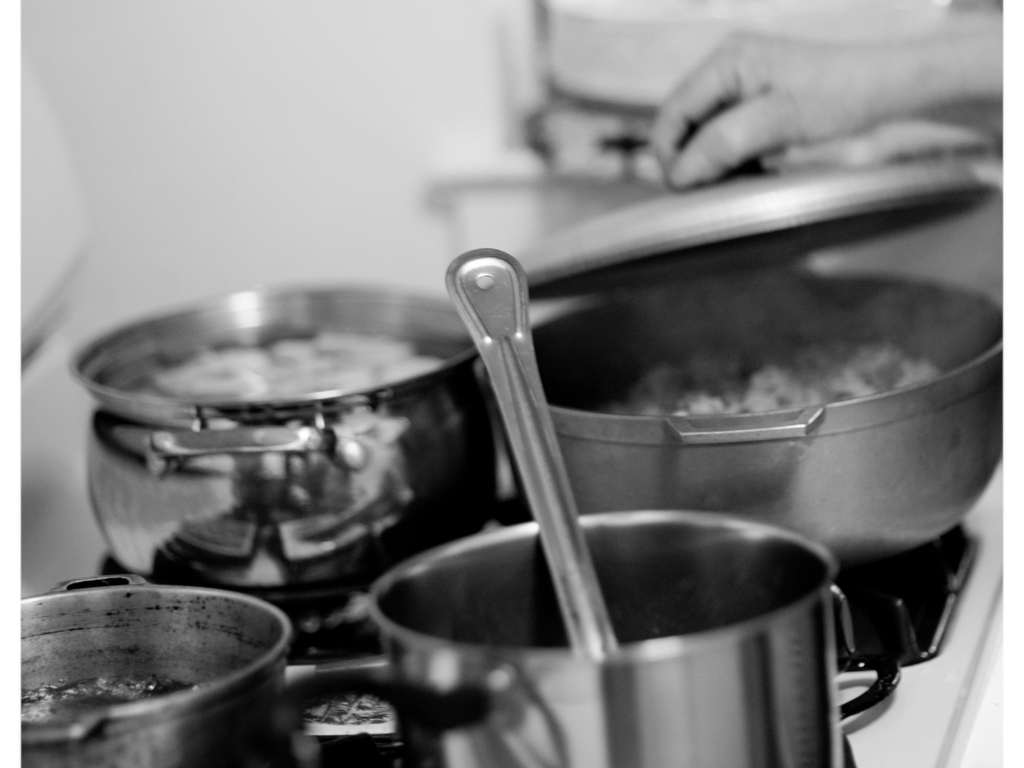Can you comment on the atmosphere of the setting? The image depicts a sense of domestic warmth and activity implied by the cooking. The steam and the focused work of the person suggest a bustling kitchen environment where a homemade meal is being diligently prepared. 